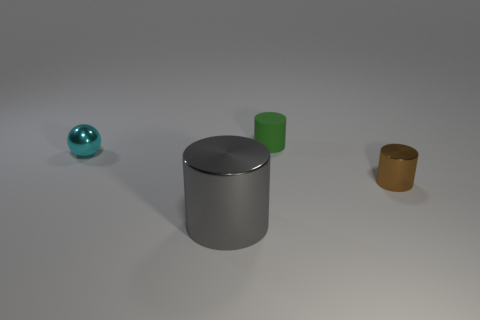Add 2 green rubber cylinders. How many objects exist? 6 Subtract all cylinders. How many objects are left? 1 Add 4 big green cylinders. How many big green cylinders exist? 4 Subtract 0 gray cubes. How many objects are left? 4 Subtract all shiny spheres. Subtract all cyan metallic things. How many objects are left? 2 Add 2 small cyan metal objects. How many small cyan metal objects are left? 3 